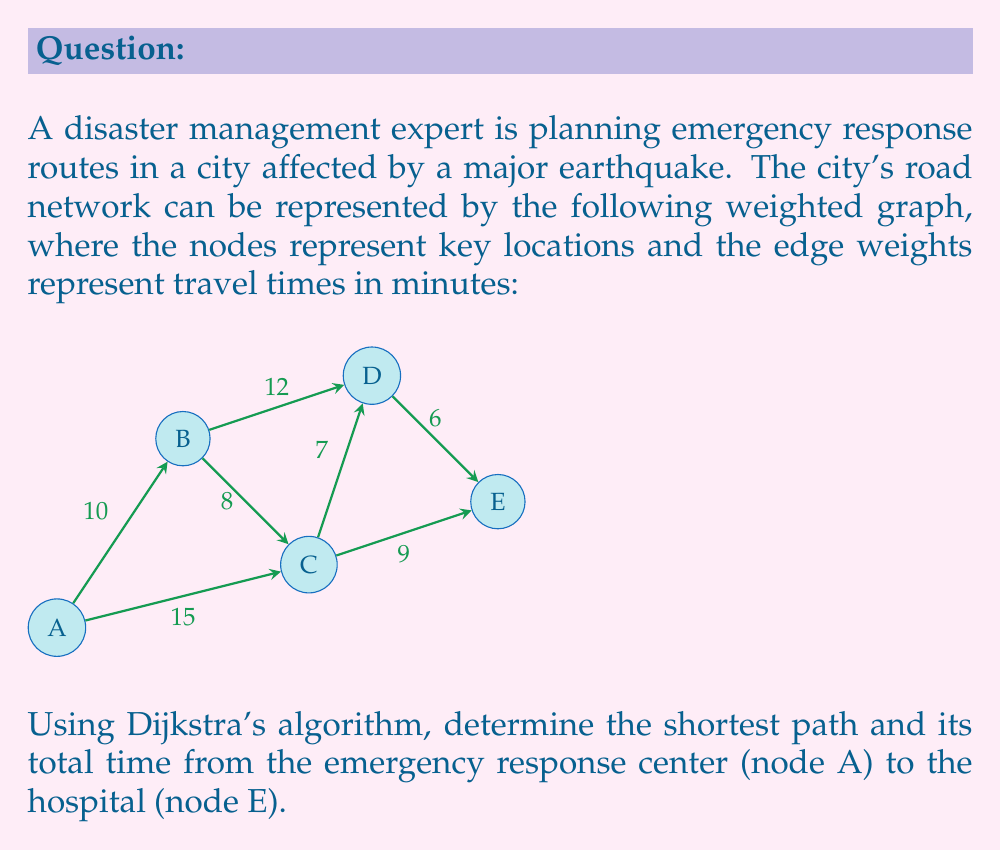Help me with this question. To solve this problem, we'll apply Dijkstra's algorithm step-by-step:

1) Initialize:
   - Set distance to A as 0, all others as infinity
   - Set all nodes as unvisited
   - Set A as the current node

2) For the current node, consider all unvisited neighbors and calculate their tentative distances:
   - A to B: 10
   - A to C: 15
   Update distances if smaller than the current recorded distance.

3) Mark A as visited. Set B as the current node (smallest tentative distance).

4) From B:
   - B to C: 10 + 8 = 18 (larger than direct A to C, no update)
   - B to D: 10 + 12 = 22

5) Mark B as visited. Set C as the current node.

6) From C:
   - C to D: 15 + 7 = 22 (same as via B)
   - C to E: 15 + 9 = 24

7) Mark C as visited. Set D as the current node.

8) From D:
   - D to E: 22 + 6 = 28 (smaller than via C, update)

9) Mark D as visited. E is the only unvisited node left.

The shortest path is therefore A → C → D → E with a total time of 28 minutes.

To verify:
$$ \text{A to C} = 15 $$
$$ \text{C to D} = 7 $$
$$ \text{D to E} = 6 $$
$$ \text{Total} = 15 + 7 + 6 = 28 \text{ minutes} $$
Answer: Path: A → C → D → E; Time: 28 minutes 